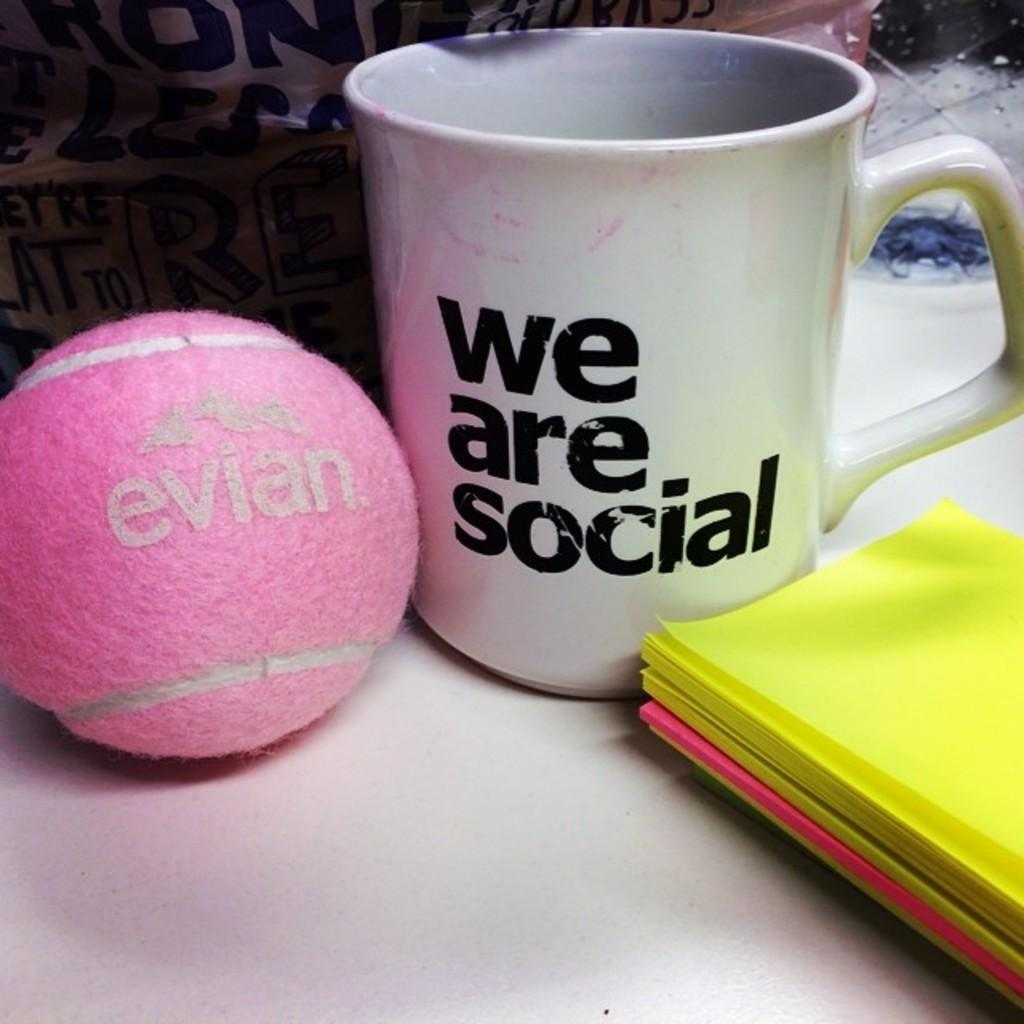What color is the ball that is visible in the image? There is a pink ball in the image. What type of papers can be seen in the image? There are yellow papers in the image. What is the container for a hot beverage in the image? There is a coffee cup in the image. What piece of furniture is present in the image? There is a desk in the image. What type of company is represented by the bird in the image? There is no bird present in the image, so it is not possible to determine what type of company it might represent. 